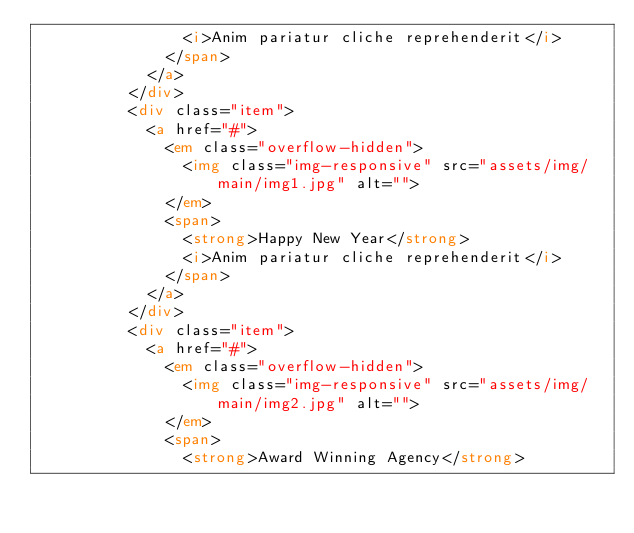Convert code to text. <code><loc_0><loc_0><loc_500><loc_500><_HTML_>								<i>Anim pariatur cliche reprehenderit</i>
							</span>
						</a>
					</div>
					<div class="item">
						<a href="#">
							<em class="overflow-hidden">
								<img class="img-responsive" src="assets/img/main/img1.jpg" alt="">
							</em>
							<span>
								<strong>Happy New Year</strong>
								<i>Anim pariatur cliche reprehenderit</i>
							</span>
						</a>
					</div>
					<div class="item">
						<a href="#">
							<em class="overflow-hidden">
								<img class="img-responsive" src="assets/img/main/img2.jpg" alt="">
							</em>
							<span>
								<strong>Award Winning Agency</strong></code> 